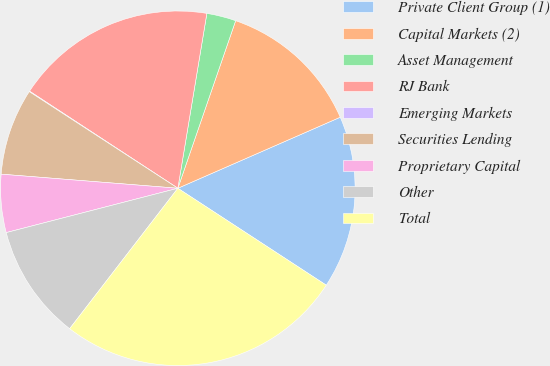<chart> <loc_0><loc_0><loc_500><loc_500><pie_chart><fcel>Private Client Group (1)<fcel>Capital Markets (2)<fcel>Asset Management<fcel>RJ Bank<fcel>Emerging Markets<fcel>Securities Lending<fcel>Proprietary Capital<fcel>Other<fcel>Total<nl><fcel>15.77%<fcel>13.15%<fcel>2.67%<fcel>18.39%<fcel>0.05%<fcel>7.91%<fcel>5.29%<fcel>10.53%<fcel>26.24%<nl></chart> 